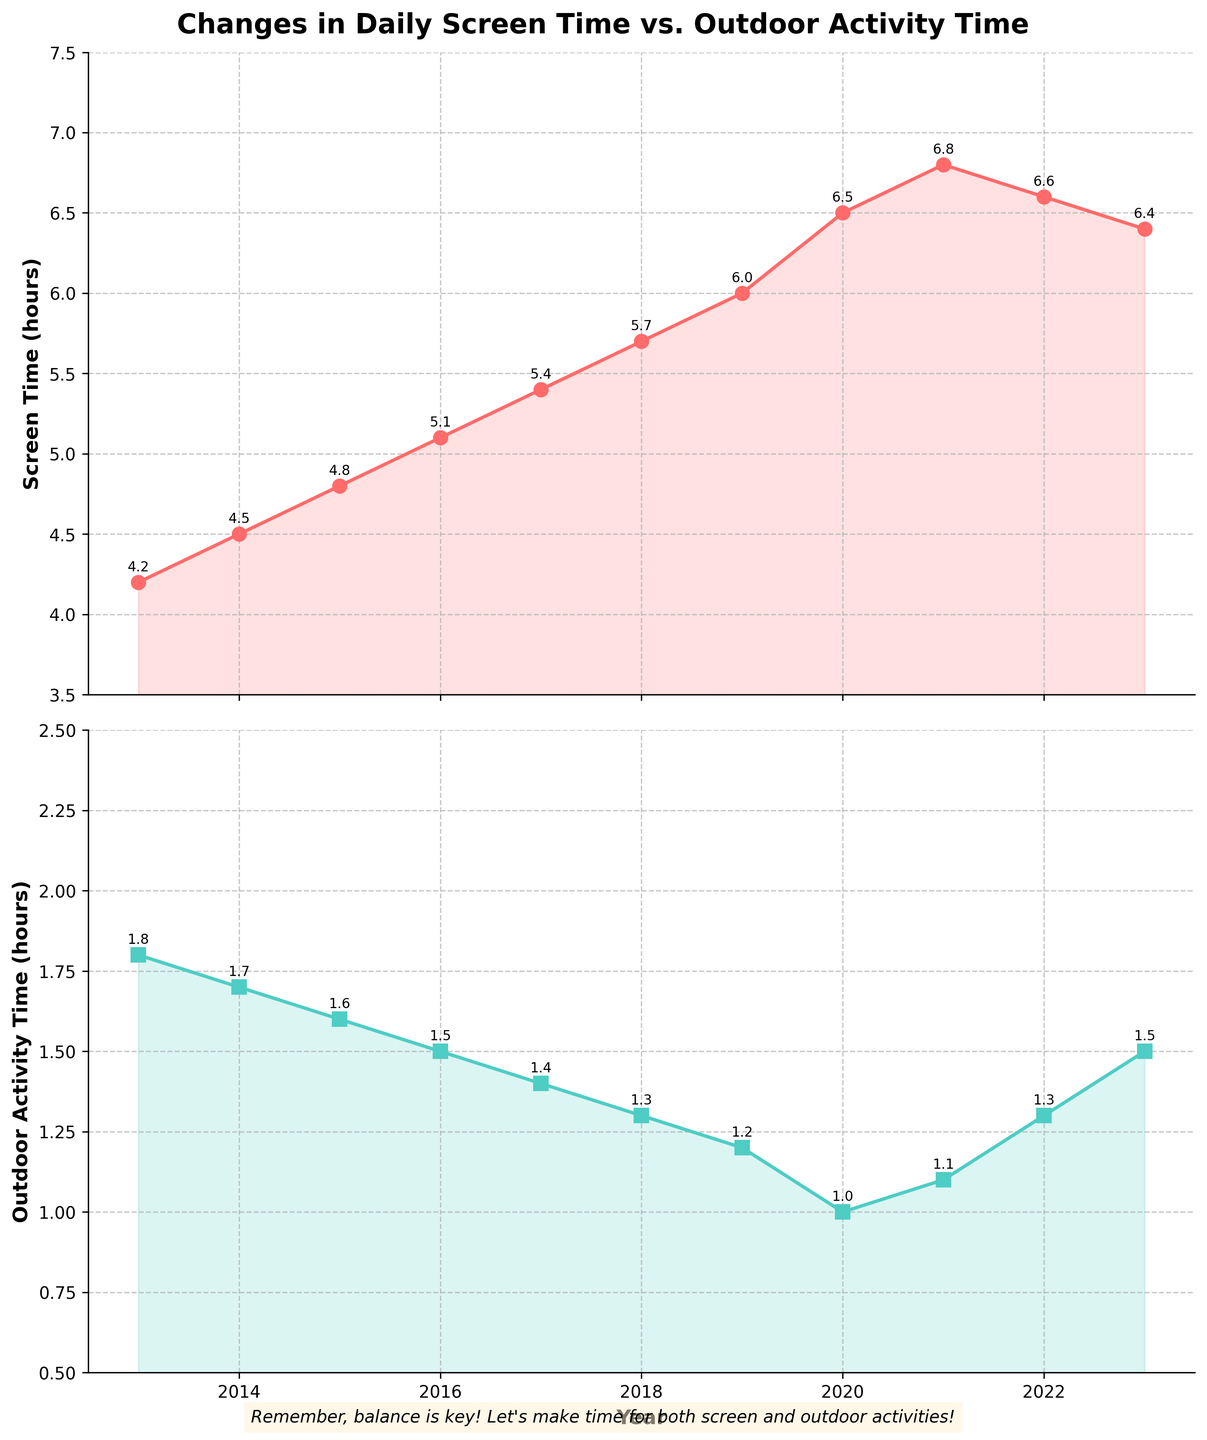What is the title of the figure? The title is usually located at the top center of the figure. Here it says "Changes in Daily Screen Time vs. Outdoor Activity Time".
Answer: Changes in Daily Screen Time vs. Outdoor Activity Time How many subplots are shown in the figure? The figure is divided into multiple smaller plots within the same area. This figure has two separate line charts, one for screen time and one for outdoor activity time.
Answer: Two What color represents screen time in the figure? By looking at the first subplot corresponding to the screen time, we observe that the line and shaded area are colored in a shade of red.
Answer: Red In which year did the screen time peak, and what was the value? We need to identify the highest point on the screen time line graph. This peak occurs in the year 2021, with a value of 6.8 hours.
Answer: 2021, 6.8 hours What is the overall trend observed in outdoor activity time from 2013 to 2023? Observing the downward trend from 2013 until 2020, followed by a slight increase from 2021 to 2023, we can identify that the general trend is initially decreasing and then slightly increasing towards the end.
Answer: Decreasing, then slight increase Which year shows the largest drop in outdoor activity time compared to the previous year, and what is the difference? By finding the year with the largest negative difference between consecutive data points on the outdoor activity time plot, we see the largest drop is from 2019 to 2020 with a difference of 0.2 hours.
Answer: 2019 to 2020, 0.2 hours Compare the screen and outdoor activity time for the year 2023. How do they differ? Looking at the values for 2023 in both subplots, screen time is 6.4 hours, and outdoor activity time is 1.5 hours. Subtracting both gives a difference of 4.9 hours.
Answer: 4.9 hours What was the average screen time between 2017 and 2020? Calculate by summing the values for 2017, 2018, 2019, and 2020 and averaging them: (5.4 + 5.7 + 6.0 + 6.5) / 4 = 5.9 hours.
Answer: 5.9 hours Was there any year where the screen time declined compared to the previous year? If yes, which year, and what was the decline? Analyzing the screen time data, we see a slight decline from 2021 to 2022 where the screen time decreased from 6.8 to 6.6 hours.
Answer: 2022, 0.2 hours 